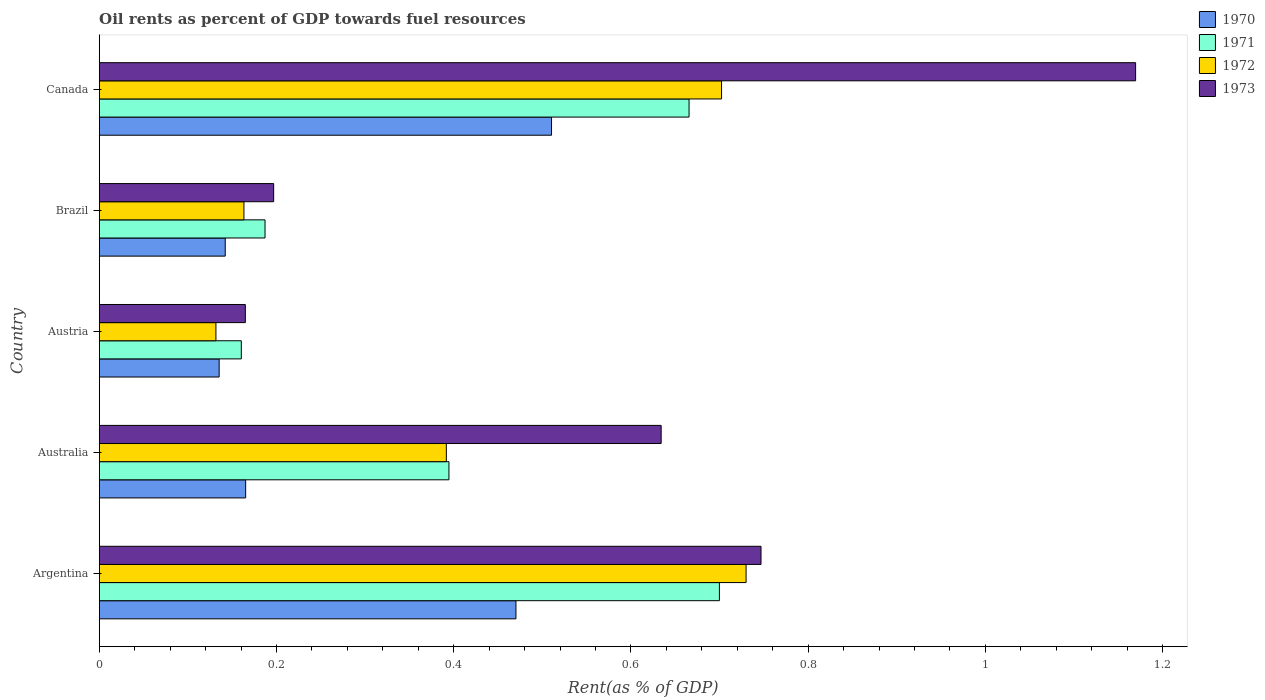How many different coloured bars are there?
Offer a terse response. 4. How many groups of bars are there?
Provide a short and direct response. 5. Are the number of bars per tick equal to the number of legend labels?
Make the answer very short. Yes. How many bars are there on the 1st tick from the bottom?
Ensure brevity in your answer.  4. What is the oil rent in 1972 in Canada?
Provide a short and direct response. 0.7. Across all countries, what is the maximum oil rent in 1972?
Give a very brief answer. 0.73. Across all countries, what is the minimum oil rent in 1971?
Give a very brief answer. 0.16. In which country was the oil rent in 1972 minimum?
Keep it short and to the point. Austria. What is the total oil rent in 1971 in the graph?
Make the answer very short. 2.11. What is the difference between the oil rent in 1971 in Australia and that in Austria?
Provide a short and direct response. 0.23. What is the difference between the oil rent in 1970 in Austria and the oil rent in 1971 in Canada?
Make the answer very short. -0.53. What is the average oil rent in 1972 per country?
Offer a very short reply. 0.42. What is the difference between the oil rent in 1970 and oil rent in 1971 in Austria?
Make the answer very short. -0.03. In how many countries, is the oil rent in 1973 greater than 0.48000000000000004 %?
Offer a terse response. 3. What is the ratio of the oil rent in 1973 in Argentina to that in Austria?
Your answer should be very brief. 4.53. What is the difference between the highest and the second highest oil rent in 1972?
Offer a very short reply. 0.03. What is the difference between the highest and the lowest oil rent in 1972?
Your answer should be very brief. 0.6. Is the sum of the oil rent in 1973 in Brazil and Canada greater than the maximum oil rent in 1972 across all countries?
Provide a short and direct response. Yes. Is it the case that in every country, the sum of the oil rent in 1973 and oil rent in 1971 is greater than the oil rent in 1970?
Give a very brief answer. Yes. How many bars are there?
Give a very brief answer. 20. How many countries are there in the graph?
Provide a succinct answer. 5. Does the graph contain any zero values?
Make the answer very short. No. How are the legend labels stacked?
Give a very brief answer. Vertical. What is the title of the graph?
Provide a succinct answer. Oil rents as percent of GDP towards fuel resources. Does "1984" appear as one of the legend labels in the graph?
Provide a short and direct response. No. What is the label or title of the X-axis?
Offer a very short reply. Rent(as % of GDP). What is the Rent(as % of GDP) in 1970 in Argentina?
Make the answer very short. 0.47. What is the Rent(as % of GDP) in 1971 in Argentina?
Offer a very short reply. 0.7. What is the Rent(as % of GDP) of 1972 in Argentina?
Your answer should be very brief. 0.73. What is the Rent(as % of GDP) in 1973 in Argentina?
Give a very brief answer. 0.75. What is the Rent(as % of GDP) of 1970 in Australia?
Ensure brevity in your answer.  0.17. What is the Rent(as % of GDP) of 1971 in Australia?
Your answer should be very brief. 0.39. What is the Rent(as % of GDP) in 1972 in Australia?
Provide a succinct answer. 0.39. What is the Rent(as % of GDP) in 1973 in Australia?
Ensure brevity in your answer.  0.63. What is the Rent(as % of GDP) of 1970 in Austria?
Offer a very short reply. 0.14. What is the Rent(as % of GDP) in 1971 in Austria?
Provide a short and direct response. 0.16. What is the Rent(as % of GDP) of 1972 in Austria?
Offer a terse response. 0.13. What is the Rent(as % of GDP) in 1973 in Austria?
Your answer should be very brief. 0.16. What is the Rent(as % of GDP) of 1970 in Brazil?
Provide a succinct answer. 0.14. What is the Rent(as % of GDP) of 1971 in Brazil?
Give a very brief answer. 0.19. What is the Rent(as % of GDP) of 1972 in Brazil?
Your answer should be compact. 0.16. What is the Rent(as % of GDP) in 1973 in Brazil?
Make the answer very short. 0.2. What is the Rent(as % of GDP) of 1970 in Canada?
Your answer should be very brief. 0.51. What is the Rent(as % of GDP) in 1971 in Canada?
Your answer should be very brief. 0.67. What is the Rent(as % of GDP) in 1972 in Canada?
Offer a very short reply. 0.7. What is the Rent(as % of GDP) of 1973 in Canada?
Provide a short and direct response. 1.17. Across all countries, what is the maximum Rent(as % of GDP) of 1970?
Provide a succinct answer. 0.51. Across all countries, what is the maximum Rent(as % of GDP) in 1971?
Provide a succinct answer. 0.7. Across all countries, what is the maximum Rent(as % of GDP) of 1972?
Give a very brief answer. 0.73. Across all countries, what is the maximum Rent(as % of GDP) in 1973?
Keep it short and to the point. 1.17. Across all countries, what is the minimum Rent(as % of GDP) in 1970?
Offer a very short reply. 0.14. Across all countries, what is the minimum Rent(as % of GDP) in 1971?
Provide a short and direct response. 0.16. Across all countries, what is the minimum Rent(as % of GDP) of 1972?
Offer a terse response. 0.13. Across all countries, what is the minimum Rent(as % of GDP) in 1973?
Your answer should be very brief. 0.16. What is the total Rent(as % of GDP) of 1970 in the graph?
Offer a very short reply. 1.42. What is the total Rent(as % of GDP) of 1971 in the graph?
Offer a very short reply. 2.11. What is the total Rent(as % of GDP) in 1972 in the graph?
Provide a short and direct response. 2.12. What is the total Rent(as % of GDP) of 1973 in the graph?
Offer a terse response. 2.91. What is the difference between the Rent(as % of GDP) in 1970 in Argentina and that in Australia?
Your response must be concise. 0.3. What is the difference between the Rent(as % of GDP) in 1971 in Argentina and that in Australia?
Provide a short and direct response. 0.31. What is the difference between the Rent(as % of GDP) in 1972 in Argentina and that in Australia?
Offer a terse response. 0.34. What is the difference between the Rent(as % of GDP) in 1973 in Argentina and that in Australia?
Your answer should be compact. 0.11. What is the difference between the Rent(as % of GDP) of 1970 in Argentina and that in Austria?
Offer a terse response. 0.33. What is the difference between the Rent(as % of GDP) of 1971 in Argentina and that in Austria?
Your answer should be very brief. 0.54. What is the difference between the Rent(as % of GDP) in 1972 in Argentina and that in Austria?
Your response must be concise. 0.6. What is the difference between the Rent(as % of GDP) of 1973 in Argentina and that in Austria?
Offer a terse response. 0.58. What is the difference between the Rent(as % of GDP) in 1970 in Argentina and that in Brazil?
Give a very brief answer. 0.33. What is the difference between the Rent(as % of GDP) in 1971 in Argentina and that in Brazil?
Your response must be concise. 0.51. What is the difference between the Rent(as % of GDP) in 1972 in Argentina and that in Brazil?
Offer a very short reply. 0.57. What is the difference between the Rent(as % of GDP) in 1973 in Argentina and that in Brazil?
Keep it short and to the point. 0.55. What is the difference between the Rent(as % of GDP) of 1970 in Argentina and that in Canada?
Your answer should be compact. -0.04. What is the difference between the Rent(as % of GDP) in 1971 in Argentina and that in Canada?
Your response must be concise. 0.03. What is the difference between the Rent(as % of GDP) in 1972 in Argentina and that in Canada?
Your response must be concise. 0.03. What is the difference between the Rent(as % of GDP) of 1973 in Argentina and that in Canada?
Offer a terse response. -0.42. What is the difference between the Rent(as % of GDP) in 1970 in Australia and that in Austria?
Ensure brevity in your answer.  0.03. What is the difference between the Rent(as % of GDP) of 1971 in Australia and that in Austria?
Give a very brief answer. 0.23. What is the difference between the Rent(as % of GDP) of 1972 in Australia and that in Austria?
Ensure brevity in your answer.  0.26. What is the difference between the Rent(as % of GDP) of 1973 in Australia and that in Austria?
Your answer should be very brief. 0.47. What is the difference between the Rent(as % of GDP) in 1970 in Australia and that in Brazil?
Give a very brief answer. 0.02. What is the difference between the Rent(as % of GDP) of 1971 in Australia and that in Brazil?
Make the answer very short. 0.21. What is the difference between the Rent(as % of GDP) of 1972 in Australia and that in Brazil?
Keep it short and to the point. 0.23. What is the difference between the Rent(as % of GDP) in 1973 in Australia and that in Brazil?
Your answer should be compact. 0.44. What is the difference between the Rent(as % of GDP) of 1970 in Australia and that in Canada?
Your answer should be very brief. -0.35. What is the difference between the Rent(as % of GDP) of 1971 in Australia and that in Canada?
Your answer should be compact. -0.27. What is the difference between the Rent(as % of GDP) in 1972 in Australia and that in Canada?
Your answer should be very brief. -0.31. What is the difference between the Rent(as % of GDP) of 1973 in Australia and that in Canada?
Give a very brief answer. -0.54. What is the difference between the Rent(as % of GDP) in 1970 in Austria and that in Brazil?
Provide a short and direct response. -0.01. What is the difference between the Rent(as % of GDP) in 1971 in Austria and that in Brazil?
Provide a succinct answer. -0.03. What is the difference between the Rent(as % of GDP) in 1972 in Austria and that in Brazil?
Offer a terse response. -0.03. What is the difference between the Rent(as % of GDP) in 1973 in Austria and that in Brazil?
Your answer should be compact. -0.03. What is the difference between the Rent(as % of GDP) of 1970 in Austria and that in Canada?
Offer a very short reply. -0.38. What is the difference between the Rent(as % of GDP) of 1971 in Austria and that in Canada?
Give a very brief answer. -0.51. What is the difference between the Rent(as % of GDP) in 1972 in Austria and that in Canada?
Provide a short and direct response. -0.57. What is the difference between the Rent(as % of GDP) of 1973 in Austria and that in Canada?
Your answer should be very brief. -1. What is the difference between the Rent(as % of GDP) in 1970 in Brazil and that in Canada?
Your response must be concise. -0.37. What is the difference between the Rent(as % of GDP) in 1971 in Brazil and that in Canada?
Offer a terse response. -0.48. What is the difference between the Rent(as % of GDP) of 1972 in Brazil and that in Canada?
Keep it short and to the point. -0.54. What is the difference between the Rent(as % of GDP) in 1973 in Brazil and that in Canada?
Give a very brief answer. -0.97. What is the difference between the Rent(as % of GDP) in 1970 in Argentina and the Rent(as % of GDP) in 1971 in Australia?
Your response must be concise. 0.08. What is the difference between the Rent(as % of GDP) in 1970 in Argentina and the Rent(as % of GDP) in 1972 in Australia?
Your response must be concise. 0.08. What is the difference between the Rent(as % of GDP) in 1970 in Argentina and the Rent(as % of GDP) in 1973 in Australia?
Give a very brief answer. -0.16. What is the difference between the Rent(as % of GDP) in 1971 in Argentina and the Rent(as % of GDP) in 1972 in Australia?
Provide a succinct answer. 0.31. What is the difference between the Rent(as % of GDP) in 1971 in Argentina and the Rent(as % of GDP) in 1973 in Australia?
Your answer should be very brief. 0.07. What is the difference between the Rent(as % of GDP) in 1972 in Argentina and the Rent(as % of GDP) in 1973 in Australia?
Make the answer very short. 0.1. What is the difference between the Rent(as % of GDP) in 1970 in Argentina and the Rent(as % of GDP) in 1971 in Austria?
Offer a terse response. 0.31. What is the difference between the Rent(as % of GDP) in 1970 in Argentina and the Rent(as % of GDP) in 1972 in Austria?
Offer a terse response. 0.34. What is the difference between the Rent(as % of GDP) in 1970 in Argentina and the Rent(as % of GDP) in 1973 in Austria?
Keep it short and to the point. 0.31. What is the difference between the Rent(as % of GDP) in 1971 in Argentina and the Rent(as % of GDP) in 1972 in Austria?
Make the answer very short. 0.57. What is the difference between the Rent(as % of GDP) of 1971 in Argentina and the Rent(as % of GDP) of 1973 in Austria?
Ensure brevity in your answer.  0.54. What is the difference between the Rent(as % of GDP) of 1972 in Argentina and the Rent(as % of GDP) of 1973 in Austria?
Your response must be concise. 0.57. What is the difference between the Rent(as % of GDP) in 1970 in Argentina and the Rent(as % of GDP) in 1971 in Brazil?
Your answer should be compact. 0.28. What is the difference between the Rent(as % of GDP) in 1970 in Argentina and the Rent(as % of GDP) in 1972 in Brazil?
Ensure brevity in your answer.  0.31. What is the difference between the Rent(as % of GDP) of 1970 in Argentina and the Rent(as % of GDP) of 1973 in Brazil?
Your answer should be very brief. 0.27. What is the difference between the Rent(as % of GDP) of 1971 in Argentina and the Rent(as % of GDP) of 1972 in Brazil?
Give a very brief answer. 0.54. What is the difference between the Rent(as % of GDP) of 1971 in Argentina and the Rent(as % of GDP) of 1973 in Brazil?
Offer a terse response. 0.5. What is the difference between the Rent(as % of GDP) in 1972 in Argentina and the Rent(as % of GDP) in 1973 in Brazil?
Offer a very short reply. 0.53. What is the difference between the Rent(as % of GDP) in 1970 in Argentina and the Rent(as % of GDP) in 1971 in Canada?
Your answer should be very brief. -0.2. What is the difference between the Rent(as % of GDP) of 1970 in Argentina and the Rent(as % of GDP) of 1972 in Canada?
Your answer should be compact. -0.23. What is the difference between the Rent(as % of GDP) in 1970 in Argentina and the Rent(as % of GDP) in 1973 in Canada?
Your answer should be compact. -0.7. What is the difference between the Rent(as % of GDP) in 1971 in Argentina and the Rent(as % of GDP) in 1972 in Canada?
Provide a succinct answer. -0. What is the difference between the Rent(as % of GDP) in 1971 in Argentina and the Rent(as % of GDP) in 1973 in Canada?
Offer a terse response. -0.47. What is the difference between the Rent(as % of GDP) of 1972 in Argentina and the Rent(as % of GDP) of 1973 in Canada?
Provide a short and direct response. -0.44. What is the difference between the Rent(as % of GDP) in 1970 in Australia and the Rent(as % of GDP) in 1971 in Austria?
Offer a very short reply. 0. What is the difference between the Rent(as % of GDP) of 1970 in Australia and the Rent(as % of GDP) of 1972 in Austria?
Provide a short and direct response. 0.03. What is the difference between the Rent(as % of GDP) in 1971 in Australia and the Rent(as % of GDP) in 1972 in Austria?
Your answer should be compact. 0.26. What is the difference between the Rent(as % of GDP) of 1971 in Australia and the Rent(as % of GDP) of 1973 in Austria?
Offer a very short reply. 0.23. What is the difference between the Rent(as % of GDP) of 1972 in Australia and the Rent(as % of GDP) of 1973 in Austria?
Your answer should be very brief. 0.23. What is the difference between the Rent(as % of GDP) in 1970 in Australia and the Rent(as % of GDP) in 1971 in Brazil?
Your response must be concise. -0.02. What is the difference between the Rent(as % of GDP) in 1970 in Australia and the Rent(as % of GDP) in 1972 in Brazil?
Ensure brevity in your answer.  0. What is the difference between the Rent(as % of GDP) of 1970 in Australia and the Rent(as % of GDP) of 1973 in Brazil?
Offer a terse response. -0.03. What is the difference between the Rent(as % of GDP) of 1971 in Australia and the Rent(as % of GDP) of 1972 in Brazil?
Ensure brevity in your answer.  0.23. What is the difference between the Rent(as % of GDP) in 1971 in Australia and the Rent(as % of GDP) in 1973 in Brazil?
Ensure brevity in your answer.  0.2. What is the difference between the Rent(as % of GDP) of 1972 in Australia and the Rent(as % of GDP) of 1973 in Brazil?
Your answer should be compact. 0.19. What is the difference between the Rent(as % of GDP) in 1970 in Australia and the Rent(as % of GDP) in 1971 in Canada?
Make the answer very short. -0.5. What is the difference between the Rent(as % of GDP) of 1970 in Australia and the Rent(as % of GDP) of 1972 in Canada?
Make the answer very short. -0.54. What is the difference between the Rent(as % of GDP) in 1970 in Australia and the Rent(as % of GDP) in 1973 in Canada?
Keep it short and to the point. -1. What is the difference between the Rent(as % of GDP) of 1971 in Australia and the Rent(as % of GDP) of 1972 in Canada?
Your answer should be very brief. -0.31. What is the difference between the Rent(as % of GDP) of 1971 in Australia and the Rent(as % of GDP) of 1973 in Canada?
Keep it short and to the point. -0.77. What is the difference between the Rent(as % of GDP) of 1972 in Australia and the Rent(as % of GDP) of 1973 in Canada?
Keep it short and to the point. -0.78. What is the difference between the Rent(as % of GDP) in 1970 in Austria and the Rent(as % of GDP) in 1971 in Brazil?
Your answer should be very brief. -0.05. What is the difference between the Rent(as % of GDP) in 1970 in Austria and the Rent(as % of GDP) in 1972 in Brazil?
Keep it short and to the point. -0.03. What is the difference between the Rent(as % of GDP) of 1970 in Austria and the Rent(as % of GDP) of 1973 in Brazil?
Keep it short and to the point. -0.06. What is the difference between the Rent(as % of GDP) in 1971 in Austria and the Rent(as % of GDP) in 1972 in Brazil?
Offer a very short reply. -0. What is the difference between the Rent(as % of GDP) of 1971 in Austria and the Rent(as % of GDP) of 1973 in Brazil?
Make the answer very short. -0.04. What is the difference between the Rent(as % of GDP) in 1972 in Austria and the Rent(as % of GDP) in 1973 in Brazil?
Provide a short and direct response. -0.07. What is the difference between the Rent(as % of GDP) of 1970 in Austria and the Rent(as % of GDP) of 1971 in Canada?
Make the answer very short. -0.53. What is the difference between the Rent(as % of GDP) in 1970 in Austria and the Rent(as % of GDP) in 1972 in Canada?
Your answer should be very brief. -0.57. What is the difference between the Rent(as % of GDP) in 1970 in Austria and the Rent(as % of GDP) in 1973 in Canada?
Provide a short and direct response. -1.03. What is the difference between the Rent(as % of GDP) of 1971 in Austria and the Rent(as % of GDP) of 1972 in Canada?
Your answer should be compact. -0.54. What is the difference between the Rent(as % of GDP) in 1971 in Austria and the Rent(as % of GDP) in 1973 in Canada?
Your response must be concise. -1.01. What is the difference between the Rent(as % of GDP) in 1972 in Austria and the Rent(as % of GDP) in 1973 in Canada?
Provide a short and direct response. -1.04. What is the difference between the Rent(as % of GDP) in 1970 in Brazil and the Rent(as % of GDP) in 1971 in Canada?
Provide a short and direct response. -0.52. What is the difference between the Rent(as % of GDP) in 1970 in Brazil and the Rent(as % of GDP) in 1972 in Canada?
Your answer should be compact. -0.56. What is the difference between the Rent(as % of GDP) in 1970 in Brazil and the Rent(as % of GDP) in 1973 in Canada?
Ensure brevity in your answer.  -1.03. What is the difference between the Rent(as % of GDP) in 1971 in Brazil and the Rent(as % of GDP) in 1972 in Canada?
Offer a very short reply. -0.52. What is the difference between the Rent(as % of GDP) in 1971 in Brazil and the Rent(as % of GDP) in 1973 in Canada?
Keep it short and to the point. -0.98. What is the difference between the Rent(as % of GDP) of 1972 in Brazil and the Rent(as % of GDP) of 1973 in Canada?
Your answer should be compact. -1.01. What is the average Rent(as % of GDP) in 1970 per country?
Keep it short and to the point. 0.28. What is the average Rent(as % of GDP) of 1971 per country?
Offer a very short reply. 0.42. What is the average Rent(as % of GDP) in 1972 per country?
Offer a terse response. 0.42. What is the average Rent(as % of GDP) in 1973 per country?
Provide a short and direct response. 0.58. What is the difference between the Rent(as % of GDP) of 1970 and Rent(as % of GDP) of 1971 in Argentina?
Your response must be concise. -0.23. What is the difference between the Rent(as % of GDP) of 1970 and Rent(as % of GDP) of 1972 in Argentina?
Give a very brief answer. -0.26. What is the difference between the Rent(as % of GDP) of 1970 and Rent(as % of GDP) of 1973 in Argentina?
Your answer should be compact. -0.28. What is the difference between the Rent(as % of GDP) of 1971 and Rent(as % of GDP) of 1972 in Argentina?
Give a very brief answer. -0.03. What is the difference between the Rent(as % of GDP) of 1971 and Rent(as % of GDP) of 1973 in Argentina?
Offer a very short reply. -0.05. What is the difference between the Rent(as % of GDP) of 1972 and Rent(as % of GDP) of 1973 in Argentina?
Make the answer very short. -0.02. What is the difference between the Rent(as % of GDP) in 1970 and Rent(as % of GDP) in 1971 in Australia?
Offer a very short reply. -0.23. What is the difference between the Rent(as % of GDP) in 1970 and Rent(as % of GDP) in 1972 in Australia?
Your response must be concise. -0.23. What is the difference between the Rent(as % of GDP) in 1970 and Rent(as % of GDP) in 1973 in Australia?
Give a very brief answer. -0.47. What is the difference between the Rent(as % of GDP) of 1971 and Rent(as % of GDP) of 1972 in Australia?
Your answer should be very brief. 0. What is the difference between the Rent(as % of GDP) in 1971 and Rent(as % of GDP) in 1973 in Australia?
Your answer should be very brief. -0.24. What is the difference between the Rent(as % of GDP) in 1972 and Rent(as % of GDP) in 1973 in Australia?
Give a very brief answer. -0.24. What is the difference between the Rent(as % of GDP) in 1970 and Rent(as % of GDP) in 1971 in Austria?
Give a very brief answer. -0.03. What is the difference between the Rent(as % of GDP) in 1970 and Rent(as % of GDP) in 1972 in Austria?
Offer a terse response. 0. What is the difference between the Rent(as % of GDP) in 1970 and Rent(as % of GDP) in 1973 in Austria?
Offer a terse response. -0.03. What is the difference between the Rent(as % of GDP) of 1971 and Rent(as % of GDP) of 1972 in Austria?
Offer a terse response. 0.03. What is the difference between the Rent(as % of GDP) in 1971 and Rent(as % of GDP) in 1973 in Austria?
Give a very brief answer. -0. What is the difference between the Rent(as % of GDP) in 1972 and Rent(as % of GDP) in 1973 in Austria?
Provide a short and direct response. -0.03. What is the difference between the Rent(as % of GDP) in 1970 and Rent(as % of GDP) in 1971 in Brazil?
Make the answer very short. -0.04. What is the difference between the Rent(as % of GDP) in 1970 and Rent(as % of GDP) in 1972 in Brazil?
Give a very brief answer. -0.02. What is the difference between the Rent(as % of GDP) in 1970 and Rent(as % of GDP) in 1973 in Brazil?
Give a very brief answer. -0.05. What is the difference between the Rent(as % of GDP) in 1971 and Rent(as % of GDP) in 1972 in Brazil?
Provide a succinct answer. 0.02. What is the difference between the Rent(as % of GDP) in 1971 and Rent(as % of GDP) in 1973 in Brazil?
Offer a terse response. -0.01. What is the difference between the Rent(as % of GDP) in 1972 and Rent(as % of GDP) in 1973 in Brazil?
Offer a very short reply. -0.03. What is the difference between the Rent(as % of GDP) of 1970 and Rent(as % of GDP) of 1971 in Canada?
Make the answer very short. -0.16. What is the difference between the Rent(as % of GDP) in 1970 and Rent(as % of GDP) in 1972 in Canada?
Provide a short and direct response. -0.19. What is the difference between the Rent(as % of GDP) in 1970 and Rent(as % of GDP) in 1973 in Canada?
Give a very brief answer. -0.66. What is the difference between the Rent(as % of GDP) of 1971 and Rent(as % of GDP) of 1972 in Canada?
Keep it short and to the point. -0.04. What is the difference between the Rent(as % of GDP) of 1971 and Rent(as % of GDP) of 1973 in Canada?
Keep it short and to the point. -0.5. What is the difference between the Rent(as % of GDP) in 1972 and Rent(as % of GDP) in 1973 in Canada?
Make the answer very short. -0.47. What is the ratio of the Rent(as % of GDP) of 1970 in Argentina to that in Australia?
Make the answer very short. 2.85. What is the ratio of the Rent(as % of GDP) in 1971 in Argentina to that in Australia?
Offer a very short reply. 1.77. What is the ratio of the Rent(as % of GDP) in 1972 in Argentina to that in Australia?
Provide a succinct answer. 1.86. What is the ratio of the Rent(as % of GDP) in 1973 in Argentina to that in Australia?
Make the answer very short. 1.18. What is the ratio of the Rent(as % of GDP) in 1970 in Argentina to that in Austria?
Your response must be concise. 3.47. What is the ratio of the Rent(as % of GDP) in 1971 in Argentina to that in Austria?
Your answer should be very brief. 4.36. What is the ratio of the Rent(as % of GDP) of 1972 in Argentina to that in Austria?
Provide a succinct answer. 5.54. What is the ratio of the Rent(as % of GDP) in 1973 in Argentina to that in Austria?
Ensure brevity in your answer.  4.53. What is the ratio of the Rent(as % of GDP) of 1970 in Argentina to that in Brazil?
Provide a short and direct response. 3.31. What is the ratio of the Rent(as % of GDP) in 1971 in Argentina to that in Brazil?
Give a very brief answer. 3.74. What is the ratio of the Rent(as % of GDP) of 1972 in Argentina to that in Brazil?
Provide a succinct answer. 4.47. What is the ratio of the Rent(as % of GDP) in 1973 in Argentina to that in Brazil?
Your answer should be very brief. 3.79. What is the ratio of the Rent(as % of GDP) in 1970 in Argentina to that in Canada?
Make the answer very short. 0.92. What is the ratio of the Rent(as % of GDP) of 1971 in Argentina to that in Canada?
Offer a terse response. 1.05. What is the ratio of the Rent(as % of GDP) in 1972 in Argentina to that in Canada?
Your response must be concise. 1.04. What is the ratio of the Rent(as % of GDP) of 1973 in Argentina to that in Canada?
Offer a terse response. 0.64. What is the ratio of the Rent(as % of GDP) of 1970 in Australia to that in Austria?
Your answer should be compact. 1.22. What is the ratio of the Rent(as % of GDP) in 1971 in Australia to that in Austria?
Ensure brevity in your answer.  2.46. What is the ratio of the Rent(as % of GDP) in 1972 in Australia to that in Austria?
Give a very brief answer. 2.97. What is the ratio of the Rent(as % of GDP) of 1973 in Australia to that in Austria?
Make the answer very short. 3.85. What is the ratio of the Rent(as % of GDP) in 1970 in Australia to that in Brazil?
Make the answer very short. 1.16. What is the ratio of the Rent(as % of GDP) of 1971 in Australia to that in Brazil?
Ensure brevity in your answer.  2.11. What is the ratio of the Rent(as % of GDP) of 1972 in Australia to that in Brazil?
Your response must be concise. 2.4. What is the ratio of the Rent(as % of GDP) in 1973 in Australia to that in Brazil?
Make the answer very short. 3.22. What is the ratio of the Rent(as % of GDP) in 1970 in Australia to that in Canada?
Your response must be concise. 0.32. What is the ratio of the Rent(as % of GDP) in 1971 in Australia to that in Canada?
Keep it short and to the point. 0.59. What is the ratio of the Rent(as % of GDP) in 1972 in Australia to that in Canada?
Provide a short and direct response. 0.56. What is the ratio of the Rent(as % of GDP) of 1973 in Australia to that in Canada?
Give a very brief answer. 0.54. What is the ratio of the Rent(as % of GDP) in 1970 in Austria to that in Brazil?
Offer a very short reply. 0.95. What is the ratio of the Rent(as % of GDP) in 1971 in Austria to that in Brazil?
Keep it short and to the point. 0.86. What is the ratio of the Rent(as % of GDP) of 1972 in Austria to that in Brazil?
Your answer should be very brief. 0.81. What is the ratio of the Rent(as % of GDP) of 1973 in Austria to that in Brazil?
Provide a short and direct response. 0.84. What is the ratio of the Rent(as % of GDP) in 1970 in Austria to that in Canada?
Provide a short and direct response. 0.27. What is the ratio of the Rent(as % of GDP) in 1971 in Austria to that in Canada?
Offer a terse response. 0.24. What is the ratio of the Rent(as % of GDP) in 1972 in Austria to that in Canada?
Keep it short and to the point. 0.19. What is the ratio of the Rent(as % of GDP) in 1973 in Austria to that in Canada?
Give a very brief answer. 0.14. What is the ratio of the Rent(as % of GDP) of 1970 in Brazil to that in Canada?
Give a very brief answer. 0.28. What is the ratio of the Rent(as % of GDP) of 1971 in Brazil to that in Canada?
Keep it short and to the point. 0.28. What is the ratio of the Rent(as % of GDP) in 1972 in Brazil to that in Canada?
Provide a succinct answer. 0.23. What is the ratio of the Rent(as % of GDP) of 1973 in Brazil to that in Canada?
Give a very brief answer. 0.17. What is the difference between the highest and the second highest Rent(as % of GDP) of 1970?
Offer a terse response. 0.04. What is the difference between the highest and the second highest Rent(as % of GDP) in 1971?
Provide a short and direct response. 0.03. What is the difference between the highest and the second highest Rent(as % of GDP) of 1972?
Provide a succinct answer. 0.03. What is the difference between the highest and the second highest Rent(as % of GDP) in 1973?
Make the answer very short. 0.42. What is the difference between the highest and the lowest Rent(as % of GDP) of 1970?
Make the answer very short. 0.38. What is the difference between the highest and the lowest Rent(as % of GDP) of 1971?
Your answer should be compact. 0.54. What is the difference between the highest and the lowest Rent(as % of GDP) in 1972?
Provide a short and direct response. 0.6. What is the difference between the highest and the lowest Rent(as % of GDP) in 1973?
Ensure brevity in your answer.  1. 